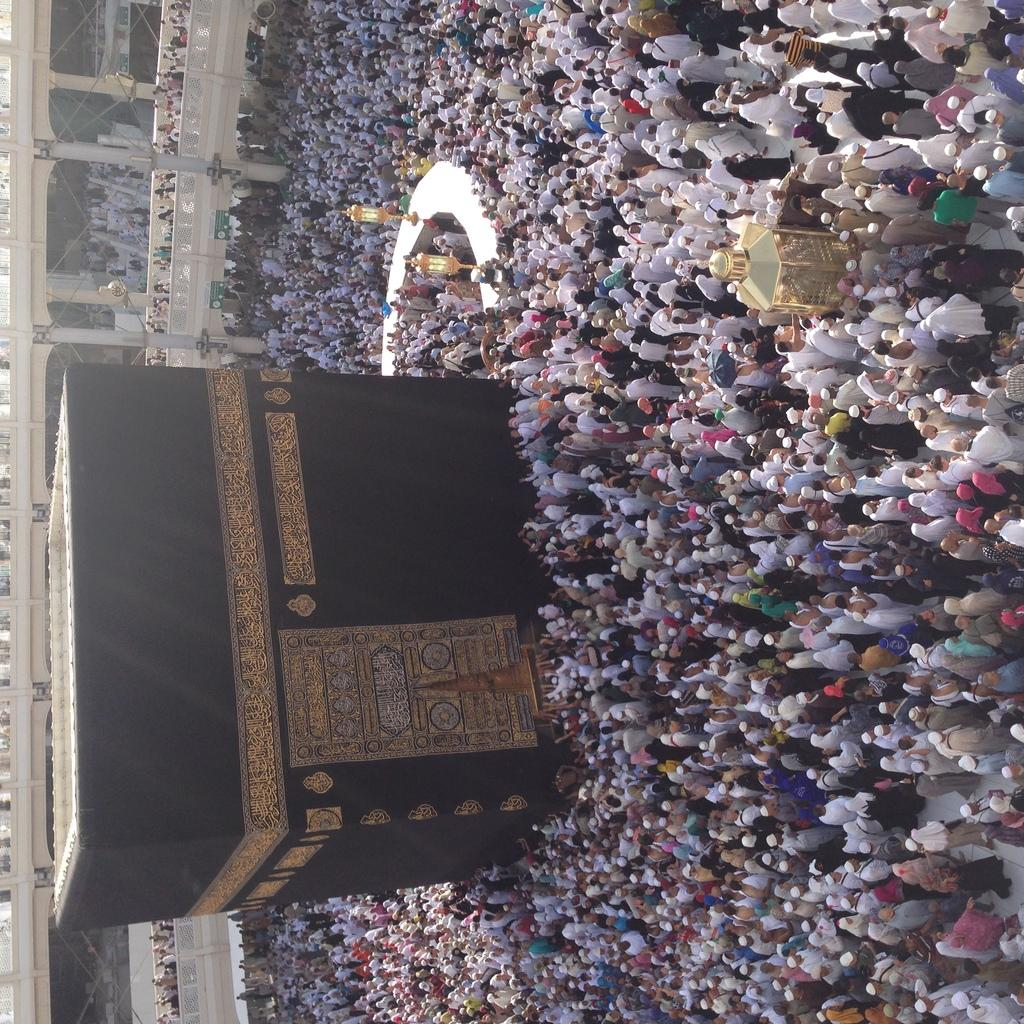What is the main subject in the center of the image? There is a hajj in the center of the image. What are the people around the hajj doing? The people are standing around the hajj. What can be seen in the background of the image? There are blocks of buildings and people visible in the background of the image. What street corner is the hajj located at in the image? The image does not show any street or corner information, so it cannot be determined from the image. 